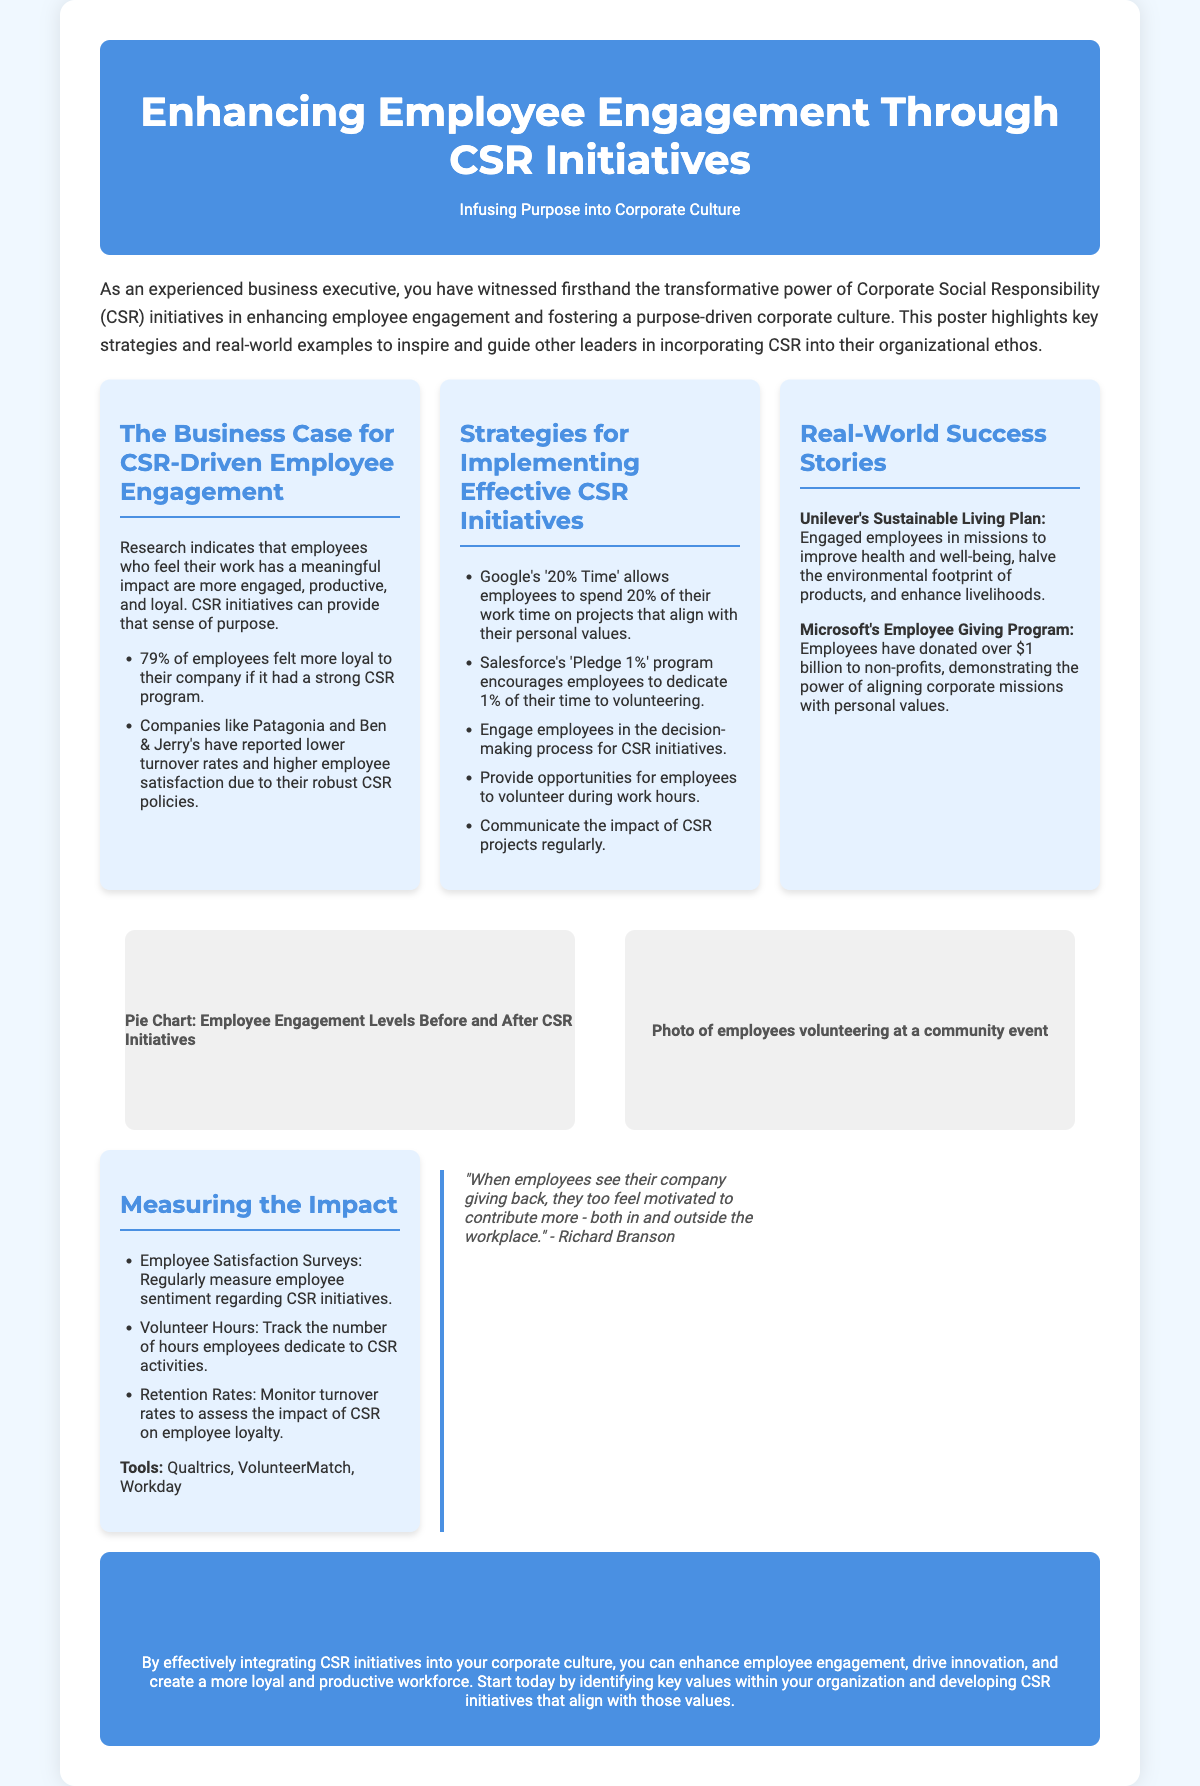What is the title of the poster? The title of the poster is stated at the top and emphasizes the focus on employee engagement through CSR initiatives.
Answer: Enhancing Employee Engagement Through CSR Initiatives What percentage of employees felt more loyal to their company with a strong CSR program? The document states that this percentage reflects the relationship between CSR and employee loyalty.
Answer: 79% Which company allows employees to spend 20% of their work time on personal projects? This company is mentioned as a leading example of CSR initiatives that align with employee values.
Answer: Google What program encourages Salesforce employees to dedicate 1% of their time? This program is an initiative aimed at promoting volunteering among employees.
Answer: Pledge 1% Which two companies are highlighted for their positive outcomes from CSR initiatives? The examples refer to well-known brands recognized for their CSR efforts and employee satisfaction.
Answer: Patagonia and Ben & Jerry's What is one of the tools mentioned for measuring employee satisfaction regarding CSR initiatives? This tool assists in gathering data about employee perceptions of CSR activities.
Answer: Qualtrics Who is quoted in the document regarding employee motivation? The quote emphasizes the connection between corporate giving and employee engagement.
Answer: Richard Branson What is the impact of effective integration of CSR initiatives according to the conclusion? The conclusion offers insight into the overall benefits of a purpose-driven corporate culture.
Answer: Enhance employee engagement What does Unilever's Sustainable Living Plan aim to improve? This initiative is aimed at enhancing several key aspects as part of their CSR efforts.
Answer: Health and well-being 